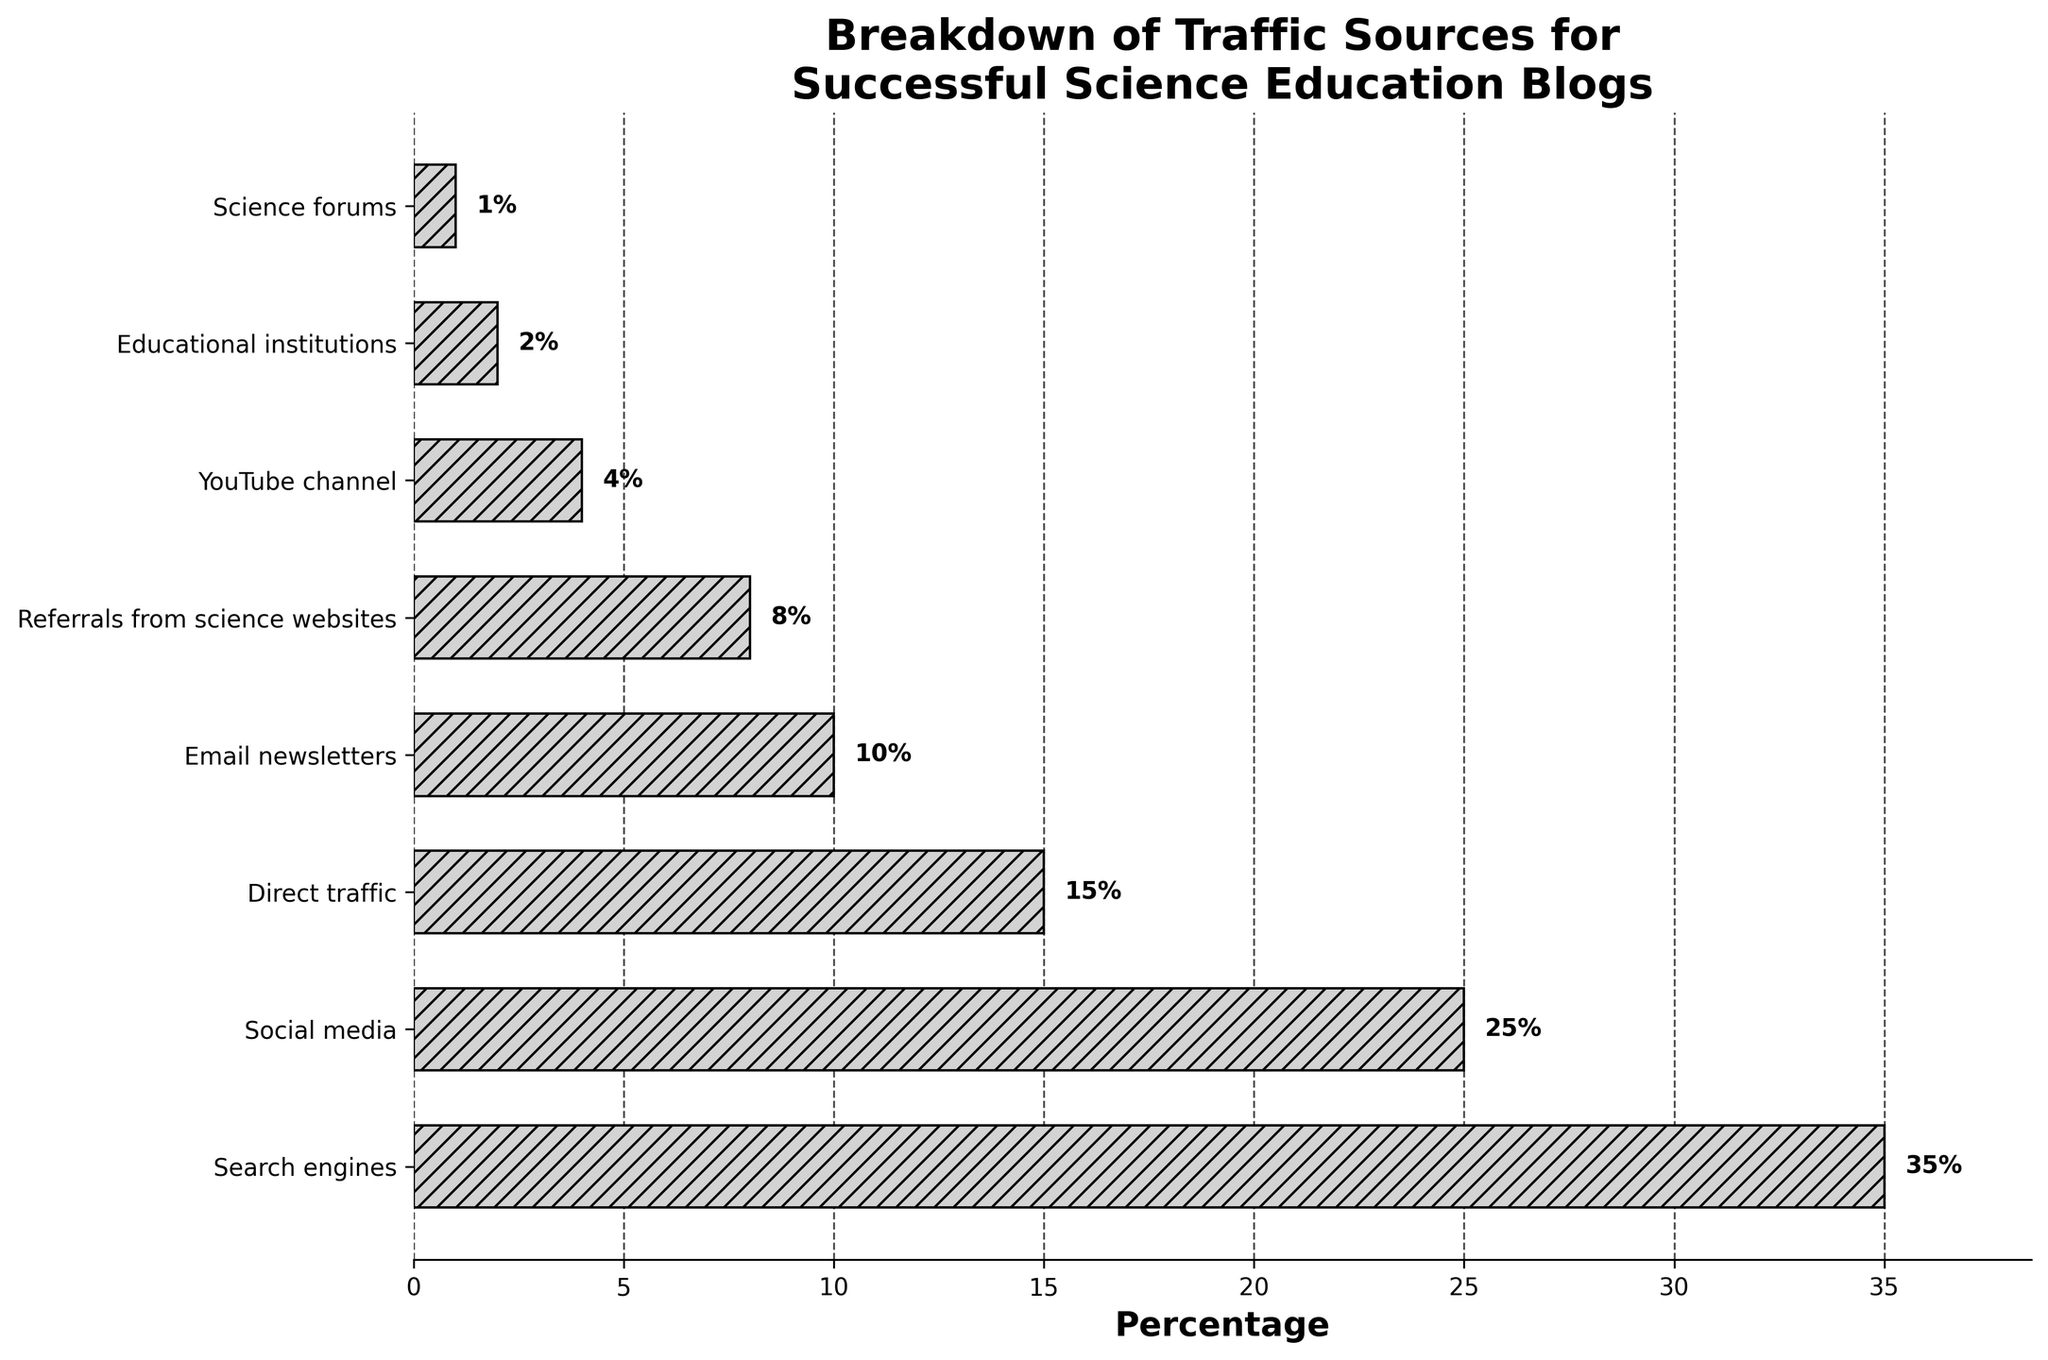what is the highest percentage traffic source shown in the figure? By looking at the length of the horizontal bars, identify the one that is longest. The label for this bar will indicate the source with the highest percentage. In this figure, the "Search engines" bar is the longest.
Answer: Search engines Which traffic source has the lowest percentage? Identify the shortest horizontal bar. The label for this bar indicates the source with the lowest percentage. In this figure, the "Science forums" bar is the shortest.
Answer: Science forums What is the combined percentage of traffic from Search engines and Social media? Locate the percentage values of both "Search engines" and "Social media" from their respective bars. Add these values together: 35% (Search engines) + 25% (Social media) = 60%.
Answer: 60% Compare the traffic percentage from Email newsletters to Referrals from science websites. Which is higher? Compare the lengths of the bars or the percentage values directly for "Email newsletters" (10%) and "Referrals from science websites" (8%). "Email newsletters" has a higher percentage.
Answer: Email newsletters How many traffic sources have percentages less than 10%? Count the number of bars that have percentage values below 10%. These sources are "Referrals from science websites", "YouTube channel", "Educational institutions", and "Science forums". There are 4 such sources.
Answer: 4 Which traffic source is exactly in the middle if sources are ranked by percentage? Rank all traffic sources from highest to lowest percentage: Search engines (35%), Social media (25%), Direct traffic (15%), Email newsletters (10%), Referrals from science websites (8%), YouTube channel (4%), Educational institutions (2%), Science forums (1%). The middle source is "Email newsletters" as it is the 4th out of 8 when ranked.
Answer: Email newsletters What is the difference in percentage between Direct traffic and YouTube channel? Find the percentage values for "Direct traffic" (15%) and "YouTube channel" (4%). Calculate the difference: 15% - 4% = 11%.
Answer: 11% What percentage of traffic comes from sources other than the top three categories? The top three categories are "Search engines" (35%), "Social media" (25%), and "Direct traffic" (15%). Sum these values: 35% + 25% + 15% = 75%. The total traffic is 100%, so the remaining traffic comes from other sources: 100% - 75% = 25%.
Answer: 25% Which bars have the hatching pattern with '///'? Observe the visual attributes of all bars. All bars in the figure have the '///' hatching pattern.
Answer: All bars Is there any traffic source with an exact 5% percentage? Check each bar’s label and corresponding percentage to see if any of them is marked as 5%. None of the listed sources have exactly 5%.
Answer: No 